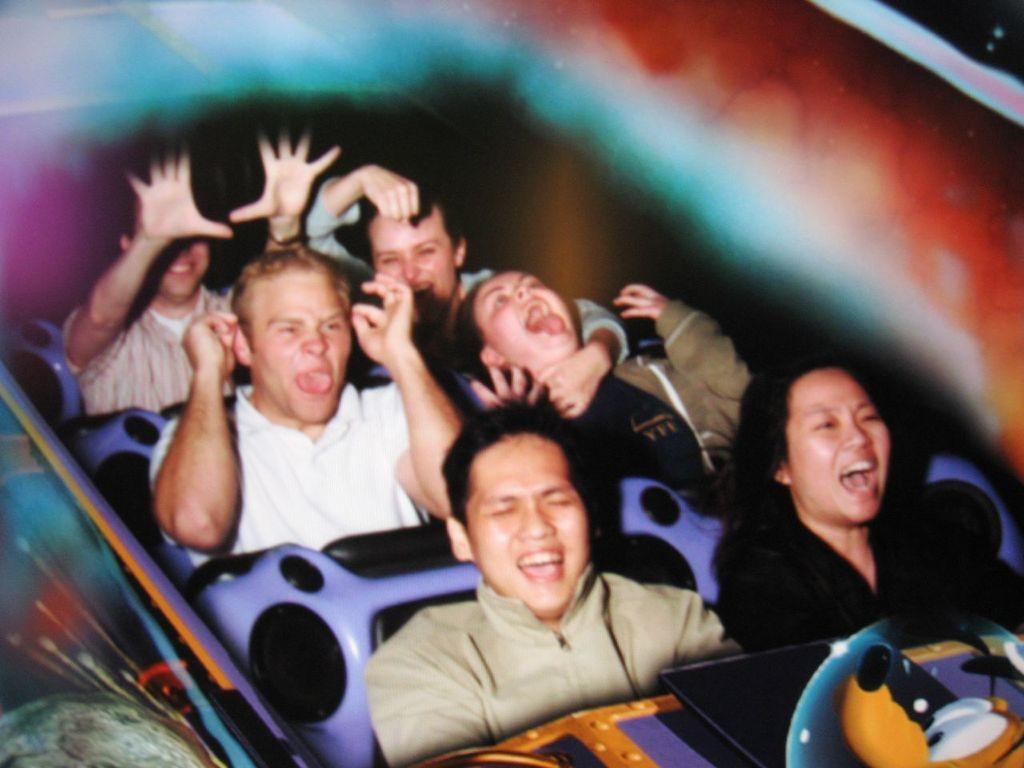What are the people in the image doing? The people in the image are sitting in a roller coaster. How do the people appear to be feeling in the image? The people are laughing, which suggests they are enjoying themselves. What can be observed about the background in the image? The background is blurred, which may indicate that the roller coaster is in motion. What type of car is parked next to the roller coaster in the image? There is no car present in the image; it only features people sitting in a roller coaster. What role does the governor play in the image? There is no governor present in the image, and therefore no role for them to play. 